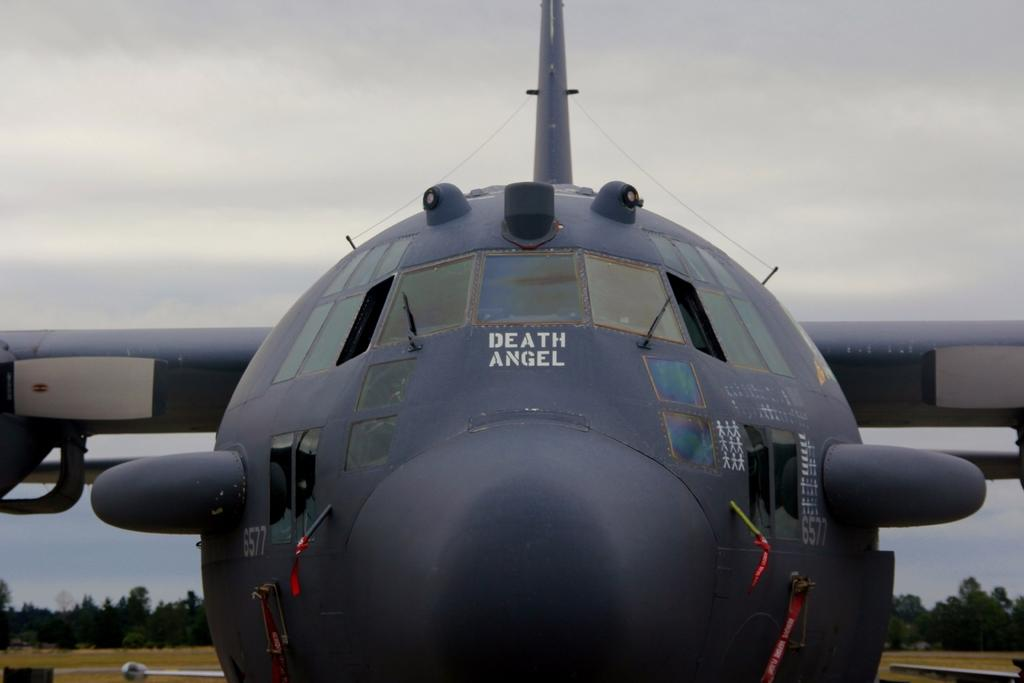<image>
Offer a succinct explanation of the picture presented. Death Angel is the name of the plane sitting here 